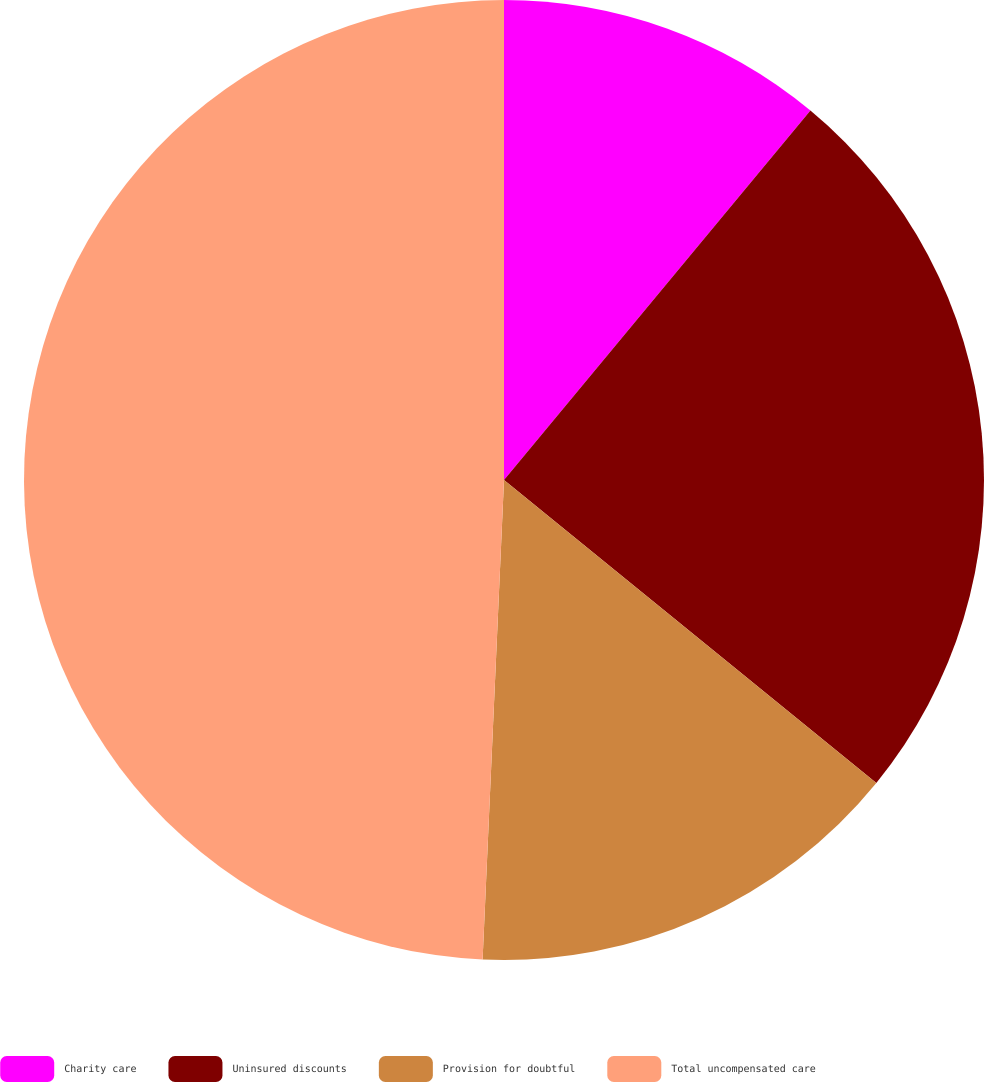Convert chart. <chart><loc_0><loc_0><loc_500><loc_500><pie_chart><fcel>Charity care<fcel>Uninsured discounts<fcel>Provision for doubtful<fcel>Total uncompensated care<nl><fcel>11.02%<fcel>24.85%<fcel>14.84%<fcel>49.29%<nl></chart> 